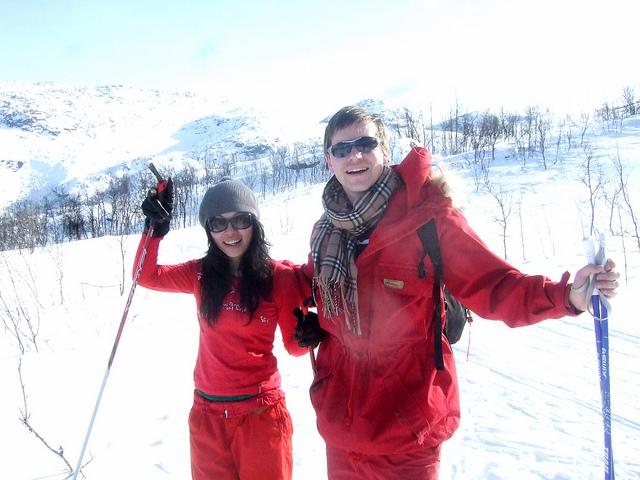What sport are they partaking in?
Concise answer only. Skiing. Which one is wearing the hat?
Answer briefly. Woman. What color are these people wearing?
Keep it brief. Red. 